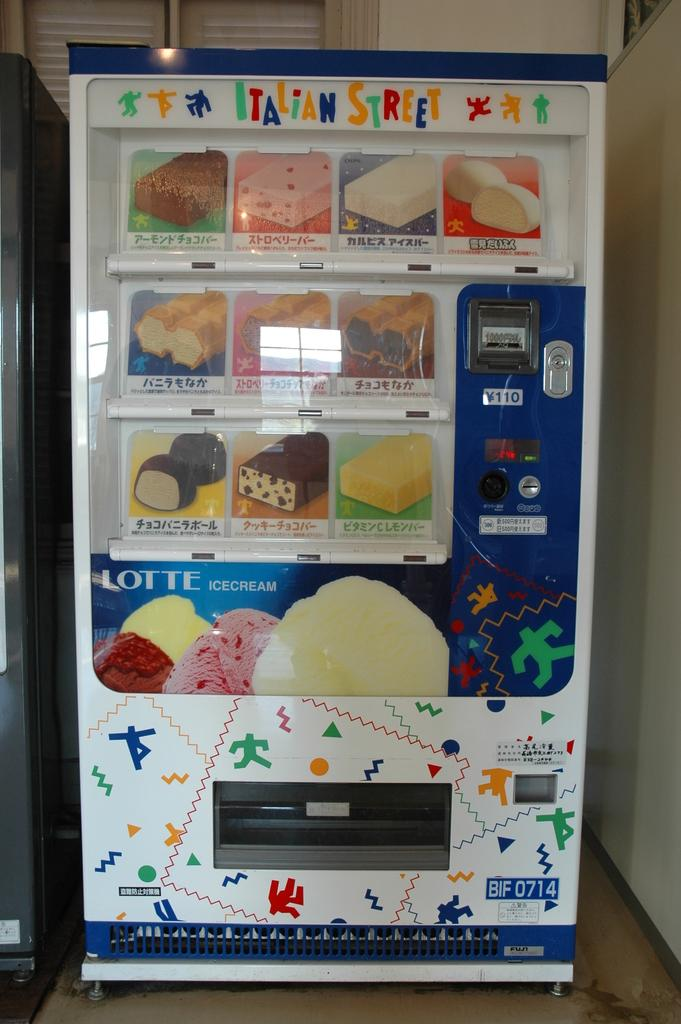<image>
Describe the image concisely. An Italian Street machine sits in the corner 